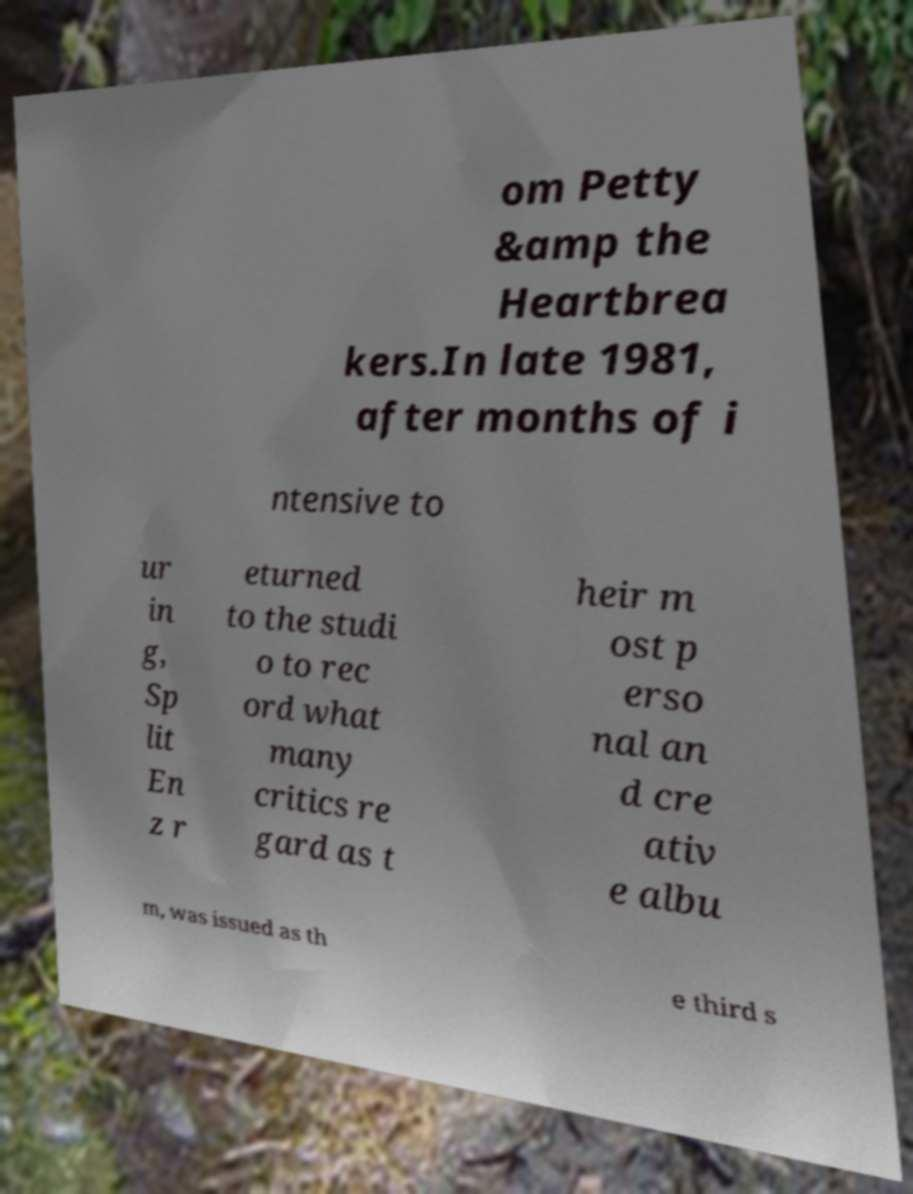Could you extract and type out the text from this image? om Petty &amp the Heartbrea kers.In late 1981, after months of i ntensive to ur in g, Sp lit En z r eturned to the studi o to rec ord what many critics re gard as t heir m ost p erso nal an d cre ativ e albu m, was issued as th e third s 